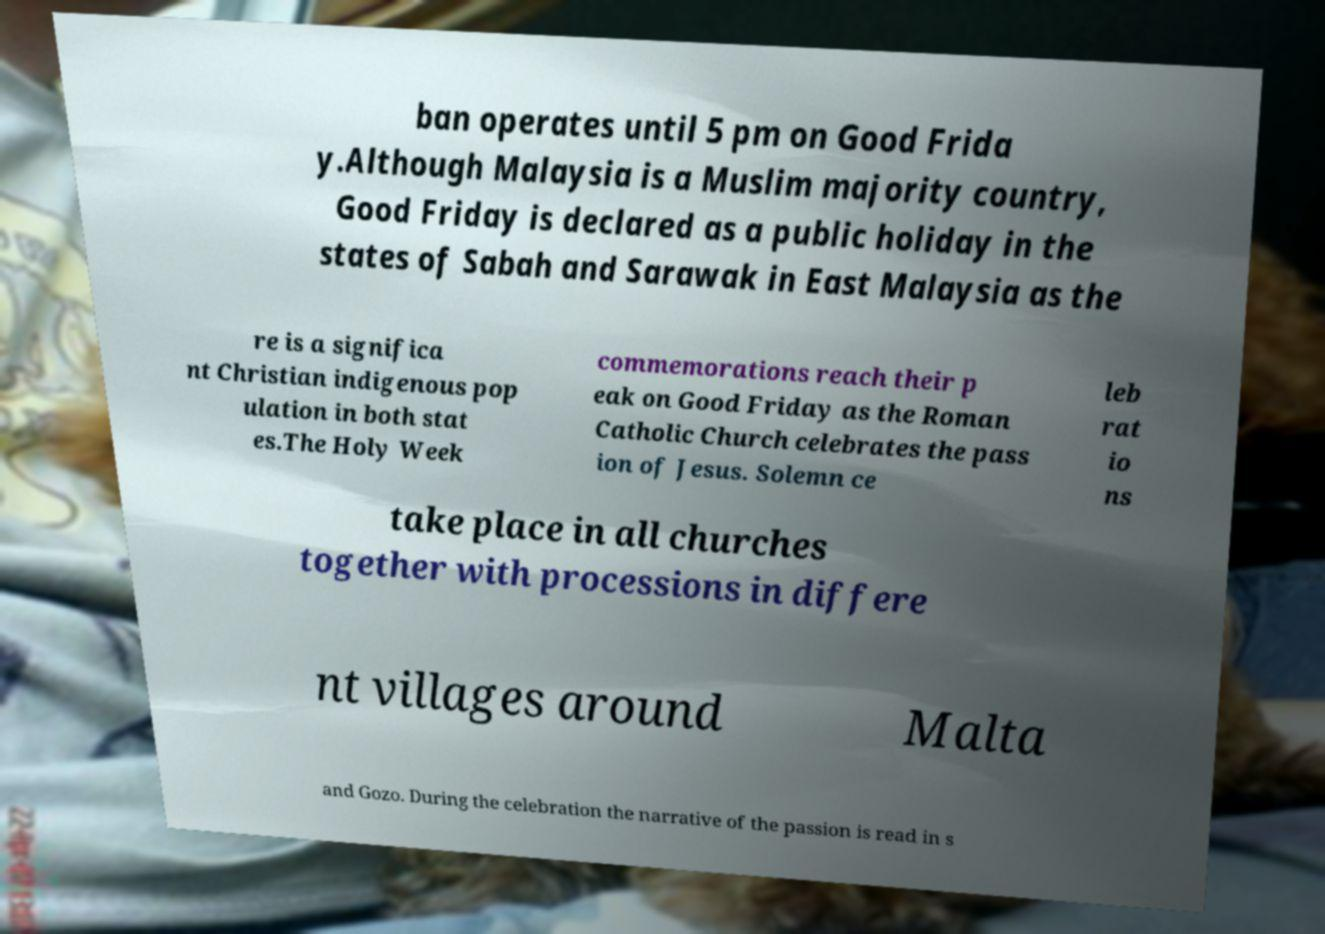Can you accurately transcribe the text from the provided image for me? ban operates until 5 pm on Good Frida y.Although Malaysia is a Muslim majority country, Good Friday is declared as a public holiday in the states of Sabah and Sarawak in East Malaysia as the re is a significa nt Christian indigenous pop ulation in both stat es.The Holy Week commemorations reach their p eak on Good Friday as the Roman Catholic Church celebrates the pass ion of Jesus. Solemn ce leb rat io ns take place in all churches together with processions in differe nt villages around Malta and Gozo. During the celebration the narrative of the passion is read in s 